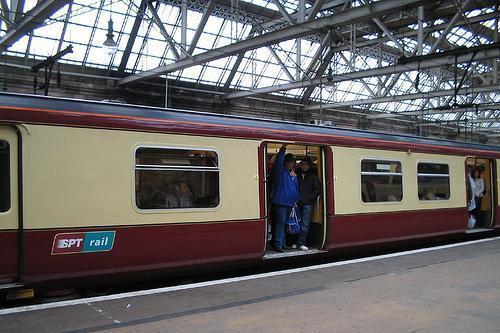How many doors are open?
Give a very brief answer. 2. 